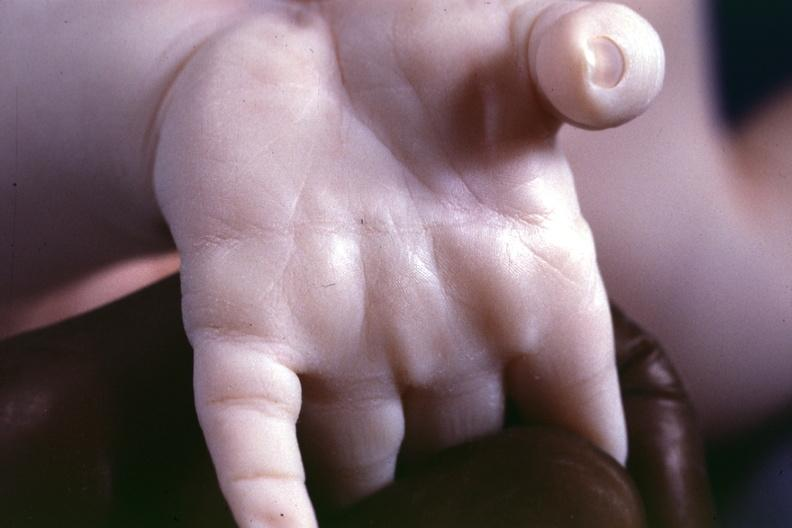what is present?
Answer the question using a single word or phrase. Hand 